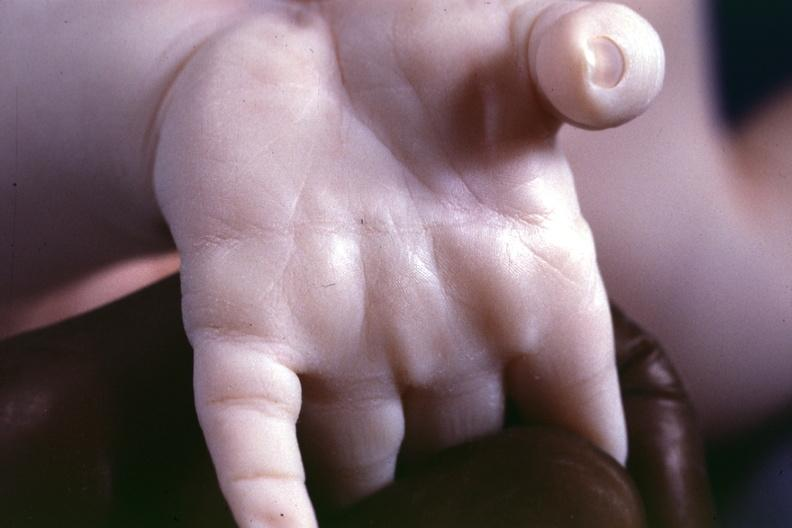what is present?
Answer the question using a single word or phrase. Hand 